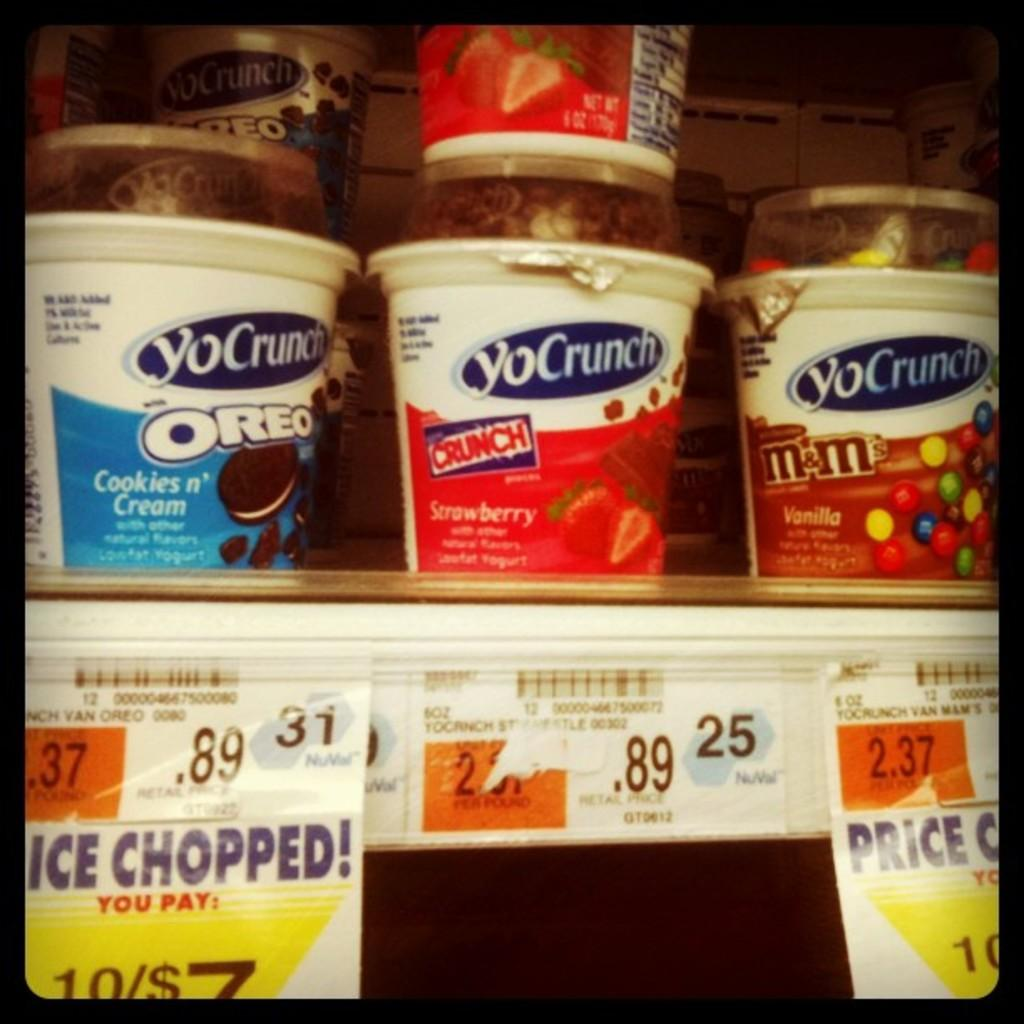What objects are visible in the image? There are cups in the image. Where can the labels be found in the image? The labels are at the bottom of the image. What type of society is depicted in the image? There is no society depicted in the image; it only features cups and labels. What role does the sand play in the image? There is no sand present in the image. How many stockings are visible in the image? There are no stockings present in the image. 